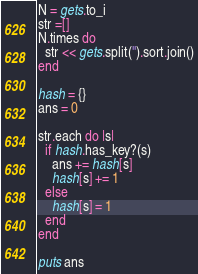<code> <loc_0><loc_0><loc_500><loc_500><_Ruby_>N = gets.to_i
str =[]
N.times do
  str << gets.split('').sort.join()
end

hash = {}
ans = 0

str.each do |s|
  if hash.has_key?(s)
    ans += hash[s]
    hash[s] += 1
  else
    hash[s] = 1
  end
end

puts ans</code> 